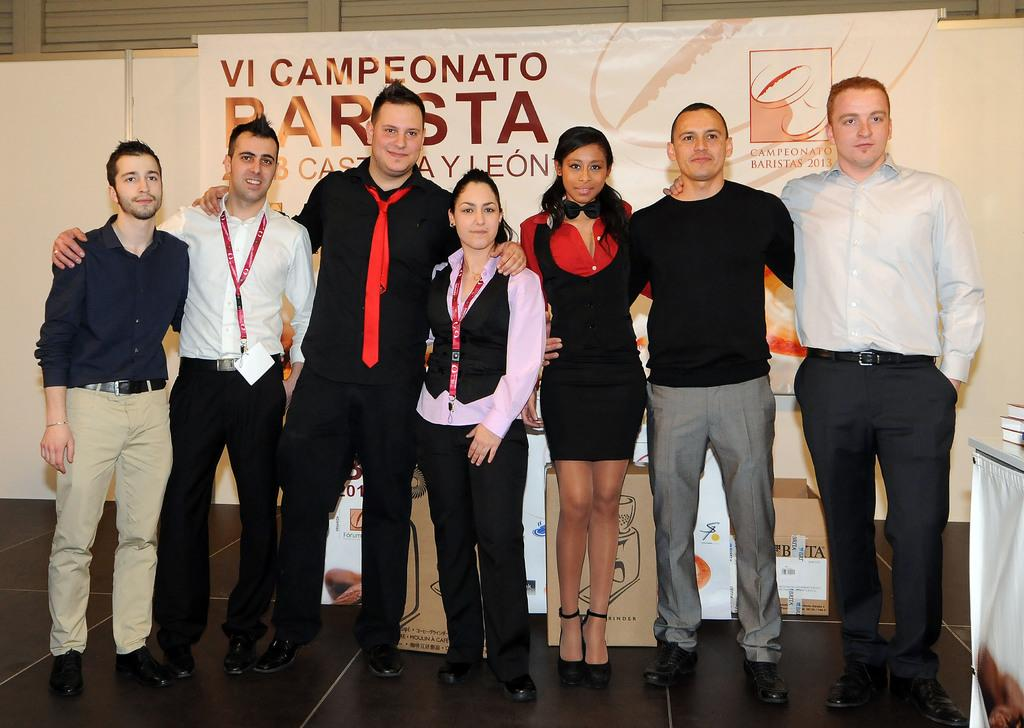What is happening in the image? There is a group of men and women in the image, and they are standing in the front and posing for the camera. What can be seen in the background of the image? There is a banner poster and brown color cardboard boxes in the background of the image. What type of hat is the man wearing in the image? There is no man wearing a hat in the image; the group is not wearing any hats. 